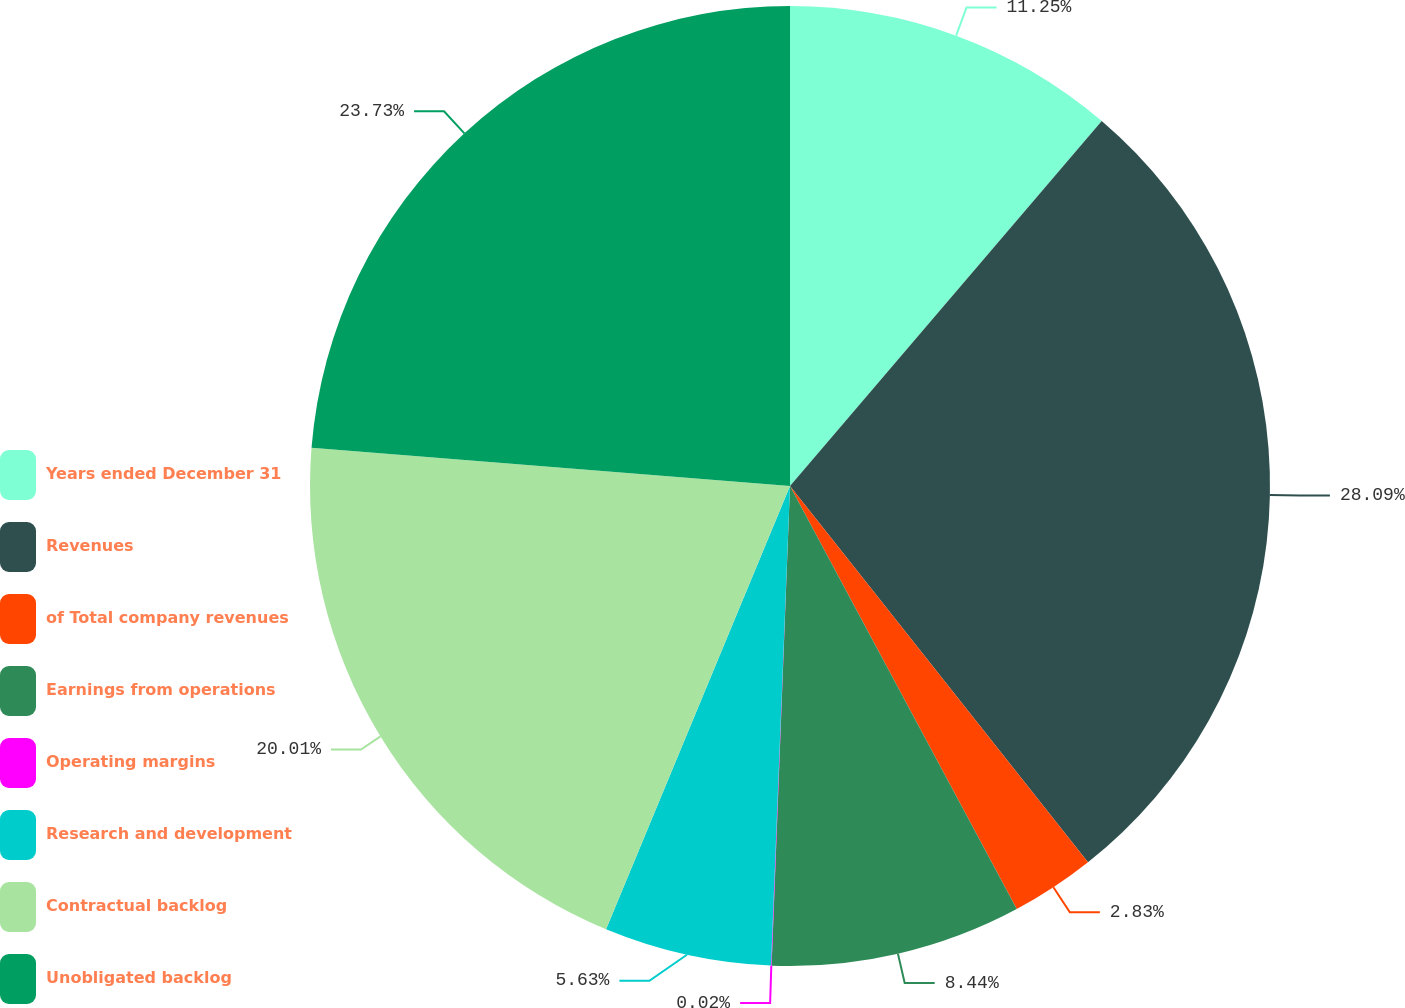<chart> <loc_0><loc_0><loc_500><loc_500><pie_chart><fcel>Years ended December 31<fcel>Revenues<fcel>of Total company revenues<fcel>Earnings from operations<fcel>Operating margins<fcel>Research and development<fcel>Contractual backlog<fcel>Unobligated backlog<nl><fcel>11.25%<fcel>28.09%<fcel>2.83%<fcel>8.44%<fcel>0.02%<fcel>5.63%<fcel>20.01%<fcel>23.73%<nl></chart> 